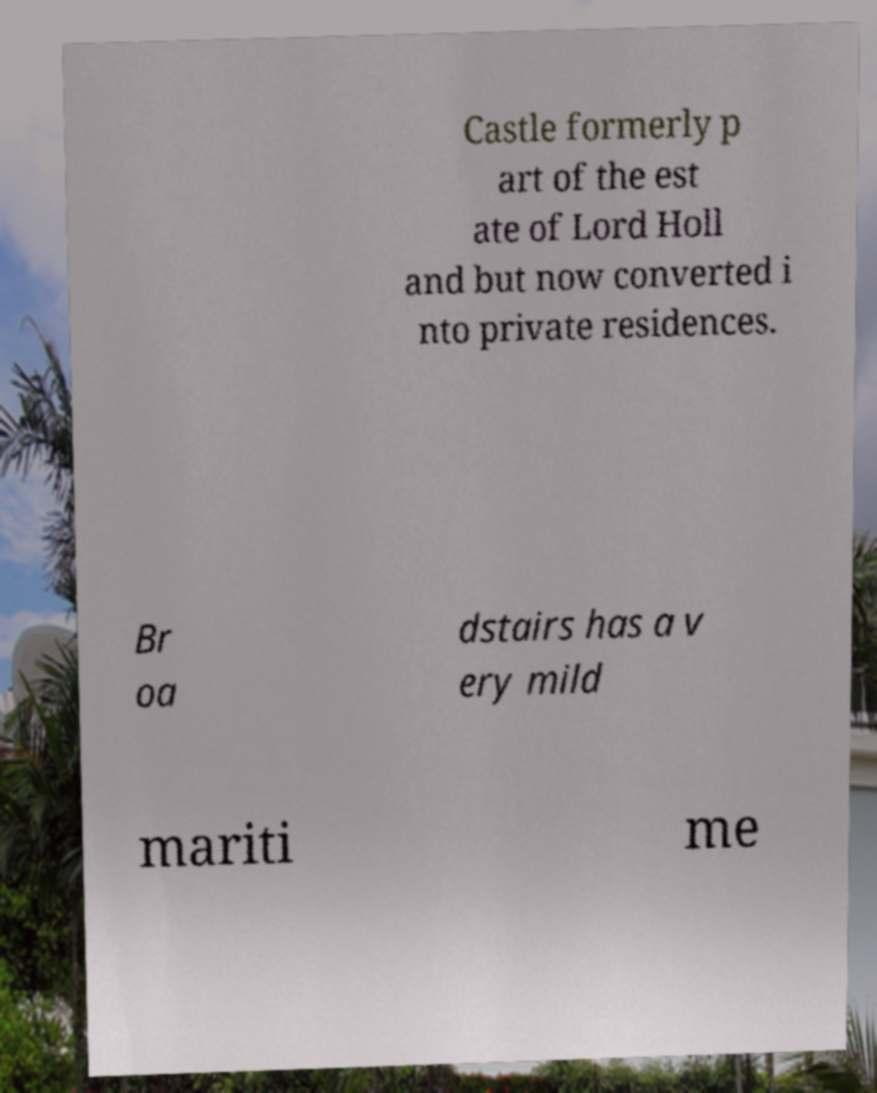Can you accurately transcribe the text from the provided image for me? Castle formerly p art of the est ate of Lord Holl and but now converted i nto private residences. Br oa dstairs has a v ery mild mariti me 